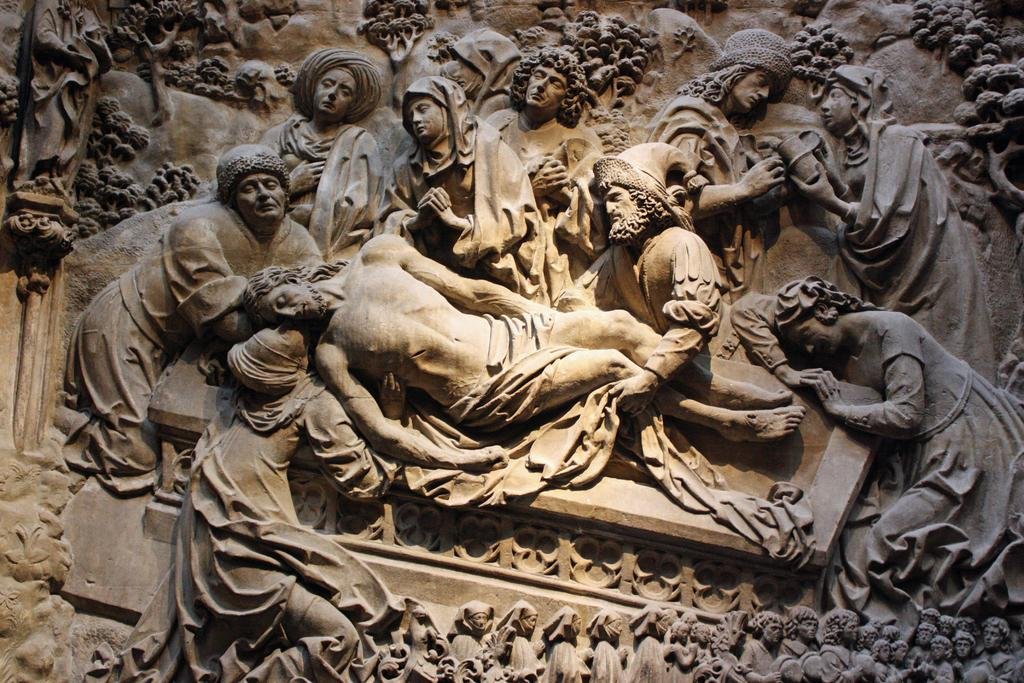What can be seen on the wall in the image? There are sculptures carved on the wall in the image. Can you describe the sculptures in more detail? Unfortunately, the provided facts do not give any additional details about the sculptures. What might be the purpose of these sculptures? The purpose of the sculptures cannot be determined from the given facts. What grade of oranges can be seen in the shop in the image? There is no mention of oranges or a shop in the image, so this question cannot be answered. 